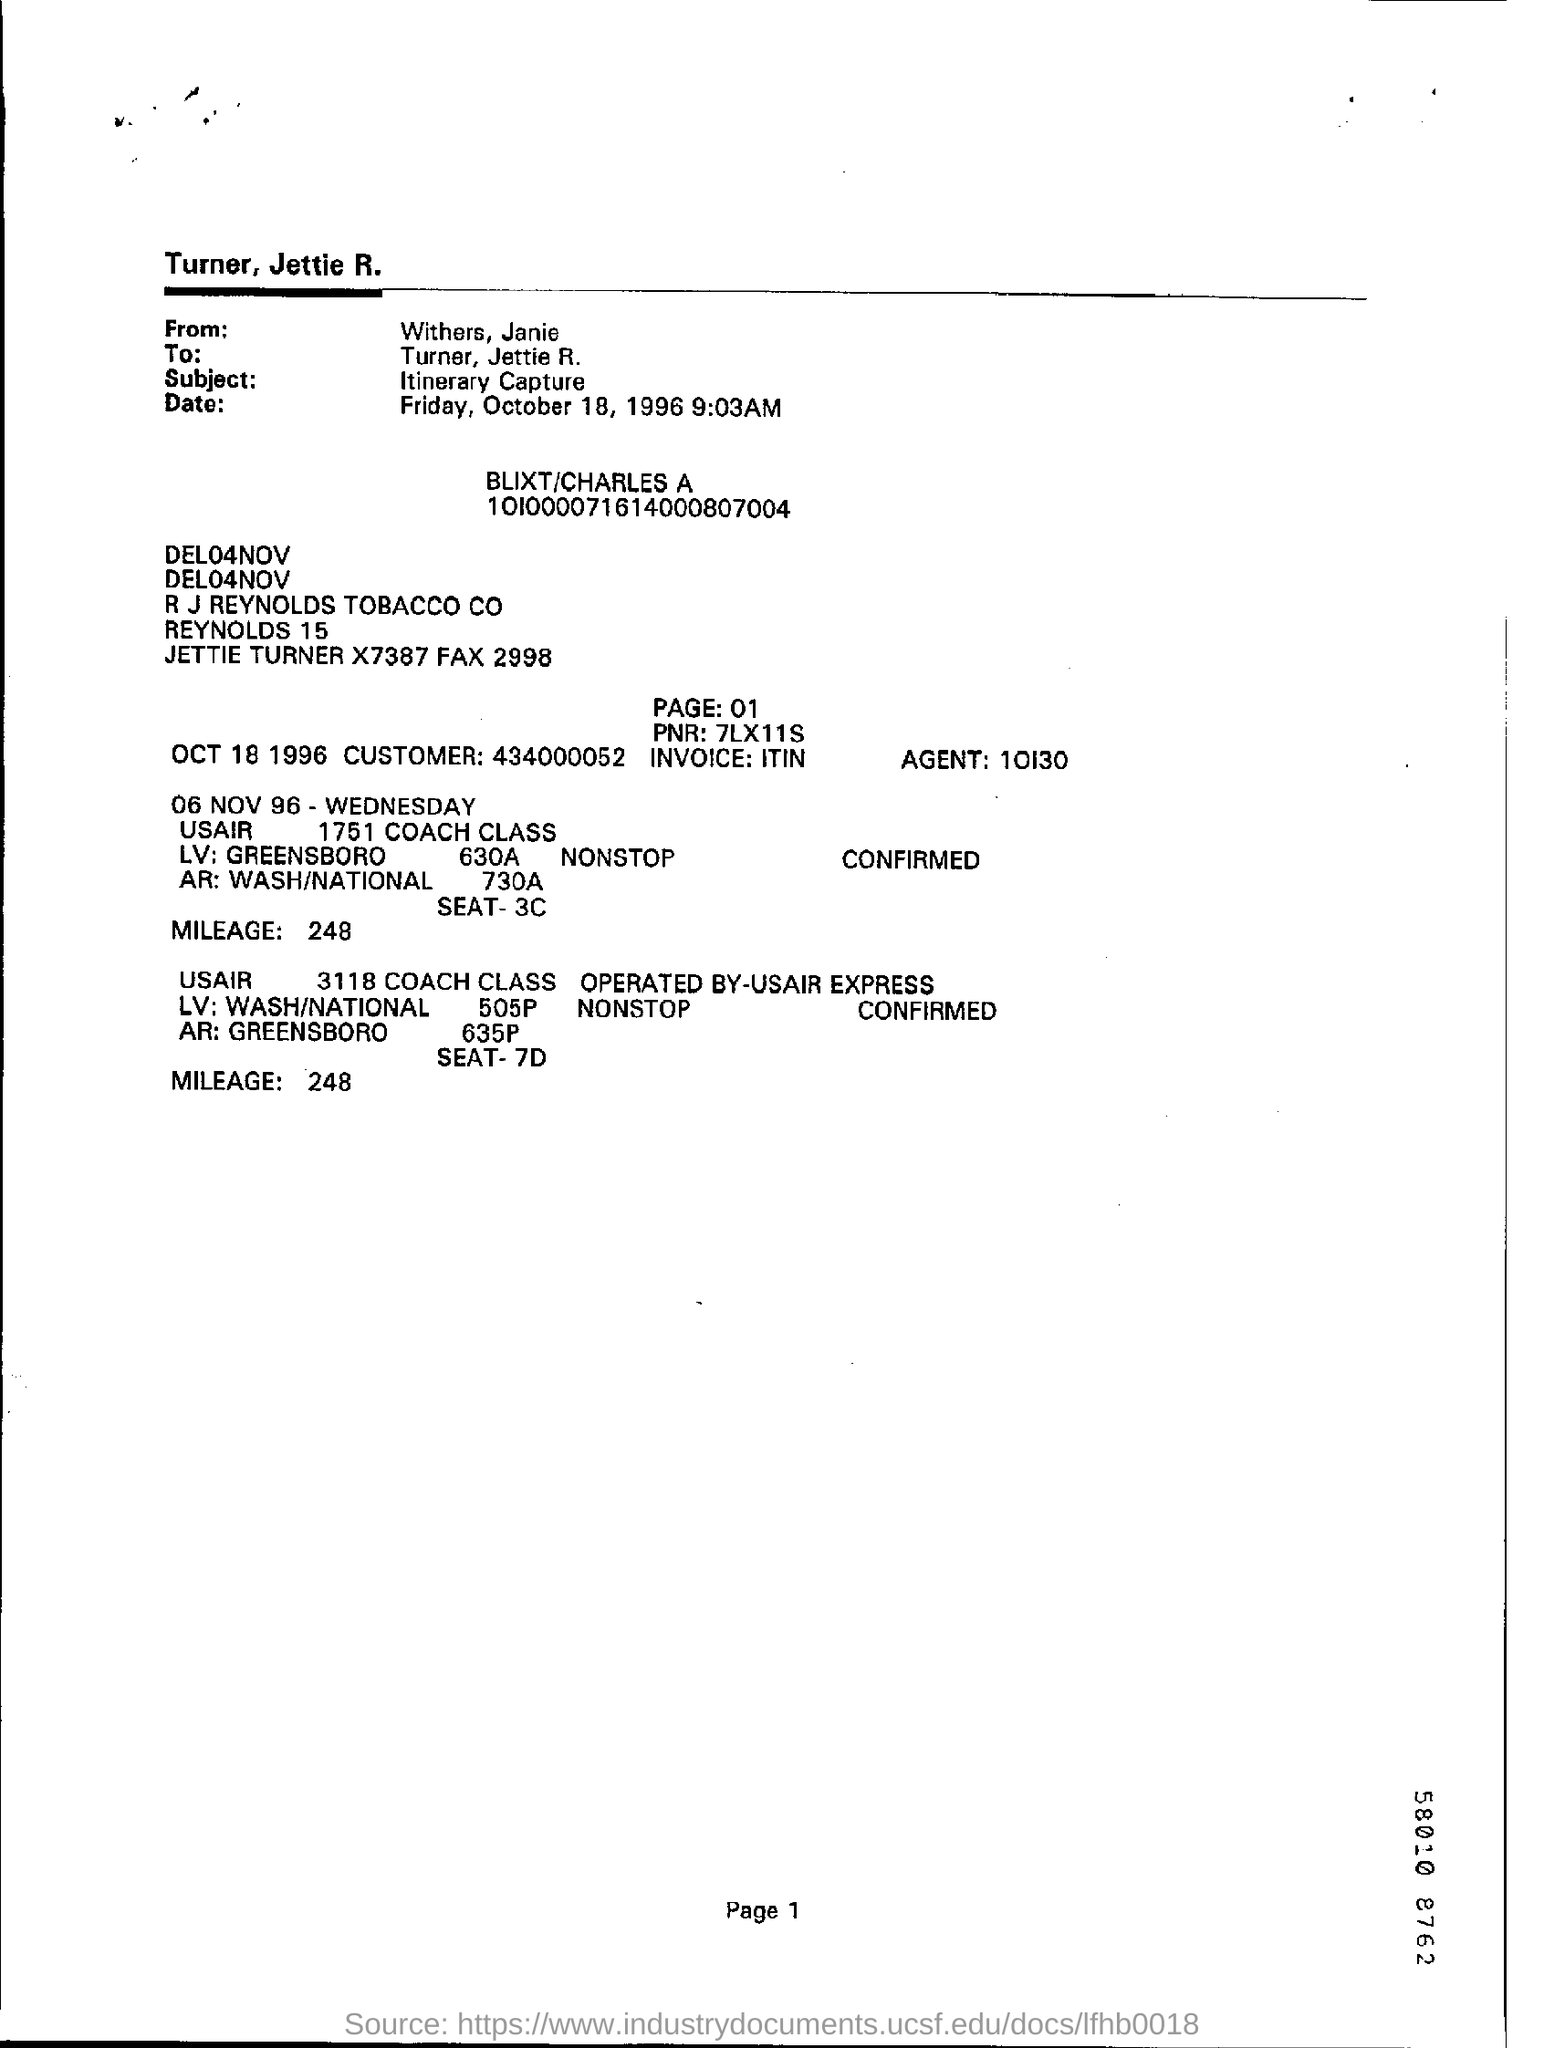Mention page number at bottom of the page ?
Your response must be concise. 1. Whom is this written from ?
Keep it short and to the point. Withers, Janie. To whom is this written ?
Make the answer very short. Turner, jettie r. What is the agent number ?
Your answer should be very brief. 10130. What is the mileage ?
Offer a terse response. 248. What is the pnr ?
Ensure brevity in your answer.  7lx11s. 